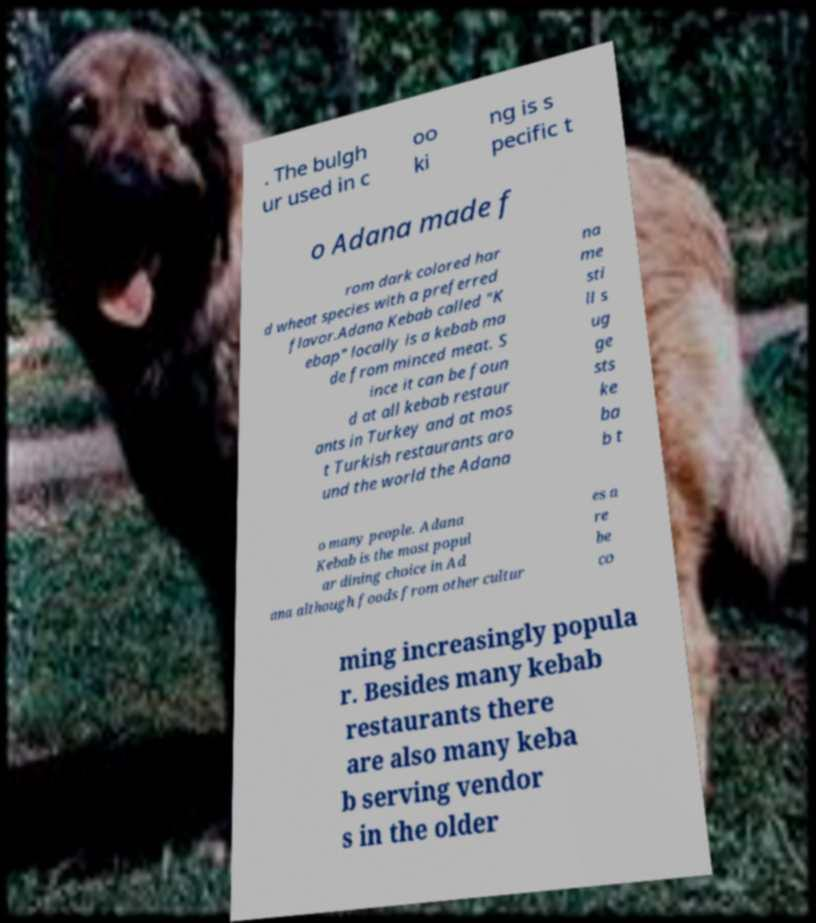Could you assist in decoding the text presented in this image and type it out clearly? . The bulgh ur used in c oo ki ng is s pecific t o Adana made f rom dark colored har d wheat species with a preferred flavor.Adana Kebab called "K ebap" locally is a kebab ma de from minced meat. S ince it can be foun d at all kebab restaur ants in Turkey and at mos t Turkish restaurants aro und the world the Adana na me sti ll s ug ge sts ke ba b t o many people. Adana Kebab is the most popul ar dining choice in Ad ana although foods from other cultur es a re be co ming increasingly popula r. Besides many kebab restaurants there are also many keba b serving vendor s in the older 